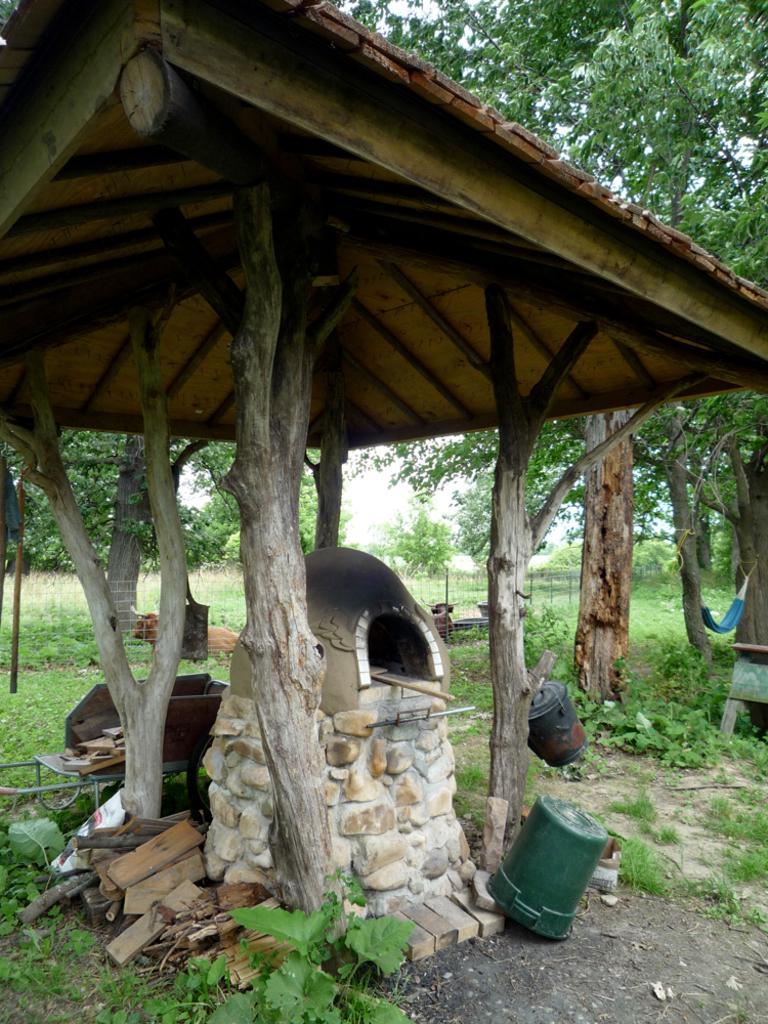Describe this image in one or two sentences. In this image there is a fireplace under the tent. There are wooden sticks and some other objects. At the bottom of the image there is grass on the surface. There are cows, metal fence, plants, trees. At the top of the image there is sky. 